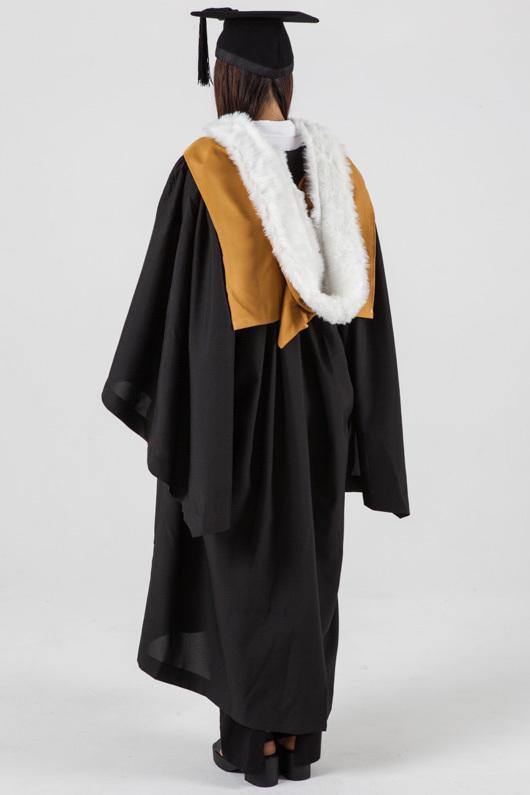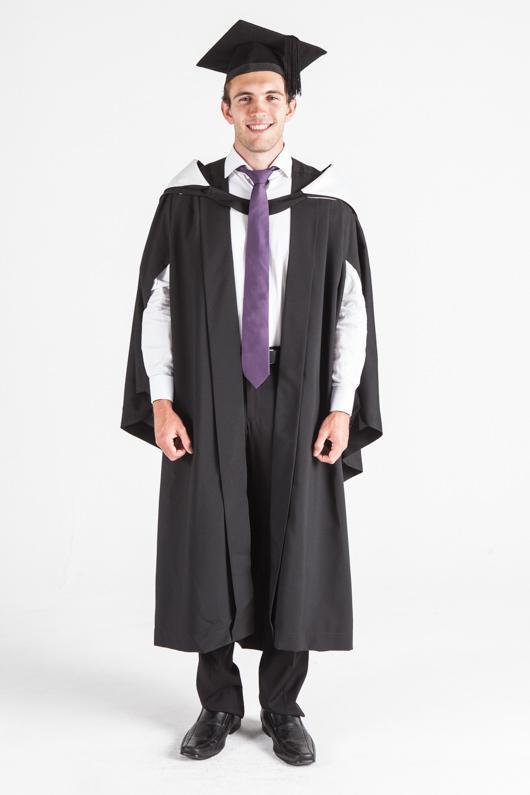The first image is the image on the left, the second image is the image on the right. Analyze the images presented: Is the assertion "One of the images features an adult male wearing a black gown and purple color tie." valid? Answer yes or no. Yes. 